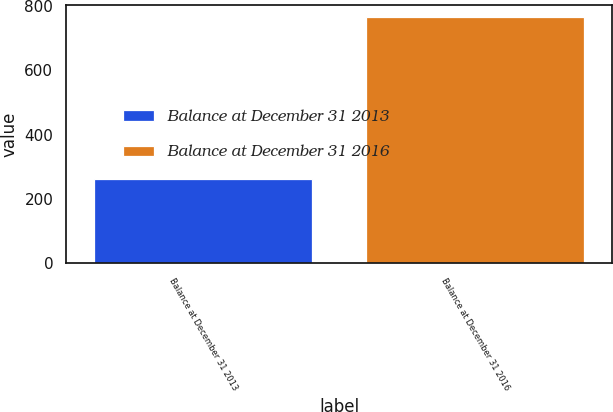Convert chart. <chart><loc_0><loc_0><loc_500><loc_500><bar_chart><fcel>Balance at December 31 2013<fcel>Balance at December 31 2016<nl><fcel>262<fcel>765<nl></chart> 